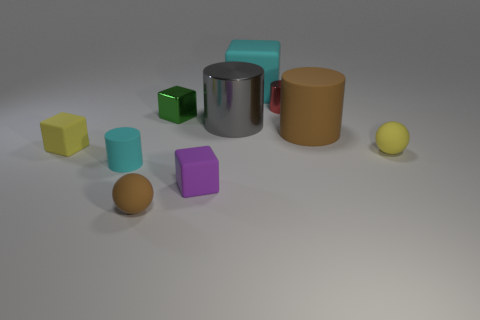What is the size of the red metallic cylinder?
Your answer should be very brief. Small. Do the green object and the red object have the same size?
Your answer should be very brief. Yes. What is the small cylinder on the right side of the tiny cyan matte cylinder made of?
Offer a terse response. Metal. There is a brown object that is the same shape as the large gray object; what is it made of?
Your answer should be very brief. Rubber. There is a cyan thing in front of the large cyan rubber thing; are there any red shiny cylinders that are left of it?
Provide a succinct answer. No. Is the green thing the same shape as the tiny purple object?
Offer a terse response. Yes. What is the shape of the tiny brown object that is the same material as the large cyan block?
Provide a short and direct response. Sphere. There is a brown thing left of the big cyan block; does it have the same size as the rubber cube to the right of the small purple cube?
Keep it short and to the point. No. Are there more tiny red cylinders that are on the left side of the gray shiny cylinder than cubes that are to the right of the tiny red cylinder?
Your answer should be very brief. No. What number of other things are the same color as the big metallic thing?
Keep it short and to the point. 0. 